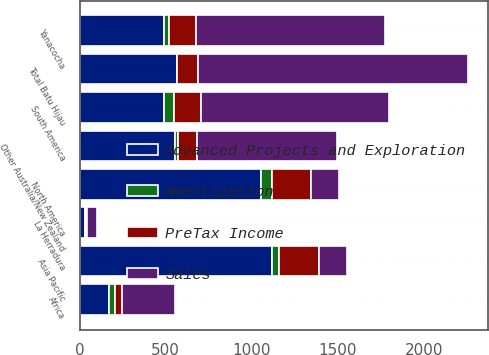<chart> <loc_0><loc_0><loc_500><loc_500><stacked_bar_chart><ecel><fcel>La Herradura<fcel>North America<fcel>Yanacocha<fcel>South America<fcel>Other Australia/New Zealand<fcel>Total Batu Hijau<fcel>Asia Pacific<fcel>Africa<nl><fcel>Sales<fcel>60<fcel>160<fcel>1093<fcel>1093<fcel>809<fcel>1572<fcel>160<fcel>306<nl><fcel>Advanced Projects and Exploration<fcel>29<fcel>1052<fcel>490<fcel>490<fcel>552<fcel>564<fcel>1116<fcel>168<nl><fcel>PreTax Income<fcel>7<fcel>227<fcel>160<fcel>160<fcel>109<fcel>121<fcel>233<fcel>43<nl><fcel>Amortization<fcel>6<fcel>67<fcel>28<fcel>55<fcel>22<fcel>1<fcel>41<fcel>36<nl></chart> 